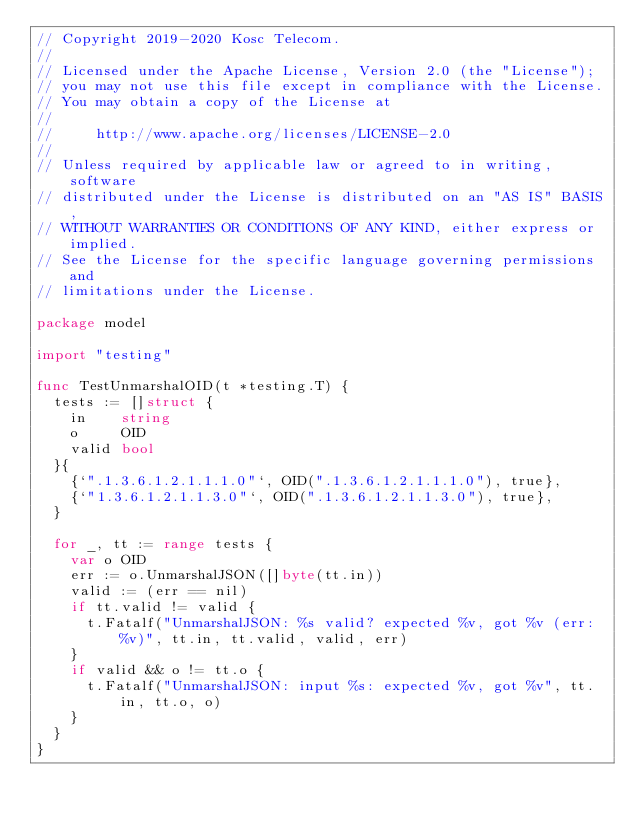Convert code to text. <code><loc_0><loc_0><loc_500><loc_500><_Go_>// Copyright 2019-2020 Kosc Telecom.
//
// Licensed under the Apache License, Version 2.0 (the "License");
// you may not use this file except in compliance with the License.
// You may obtain a copy of the License at
//
//     http://www.apache.org/licenses/LICENSE-2.0
//
// Unless required by applicable law or agreed to in writing, software
// distributed under the License is distributed on an "AS IS" BASIS,
// WITHOUT WARRANTIES OR CONDITIONS OF ANY KIND, either express or implied.
// See the License for the specific language governing permissions and
// limitations under the License.

package model

import "testing"

func TestUnmarshalOID(t *testing.T) {
	tests := []struct {
		in    string
		o     OID
		valid bool
	}{
		{`".1.3.6.1.2.1.1.1.0"`, OID(".1.3.6.1.2.1.1.1.0"), true},
		{`"1.3.6.1.2.1.1.3.0"`, OID(".1.3.6.1.2.1.1.3.0"), true},
	}

	for _, tt := range tests {
		var o OID
		err := o.UnmarshalJSON([]byte(tt.in))
		valid := (err == nil)
		if tt.valid != valid {
			t.Fatalf("UnmarshalJSON: %s valid? expected %v, got %v (err: %v)", tt.in, tt.valid, valid, err)
		}
		if valid && o != tt.o {
			t.Fatalf("UnmarshalJSON: input %s: expected %v, got %v", tt.in, tt.o, o)
		}
	}
}
</code> 